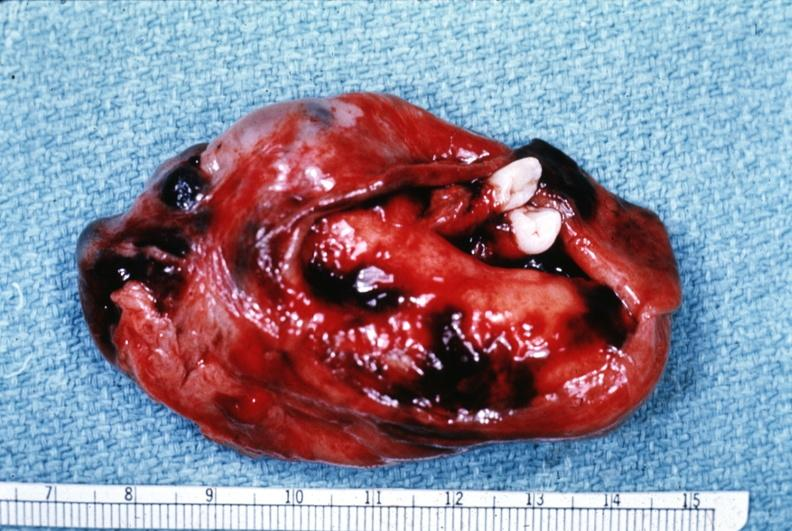what is present?
Answer the question using a single word or phrase. Ovary 